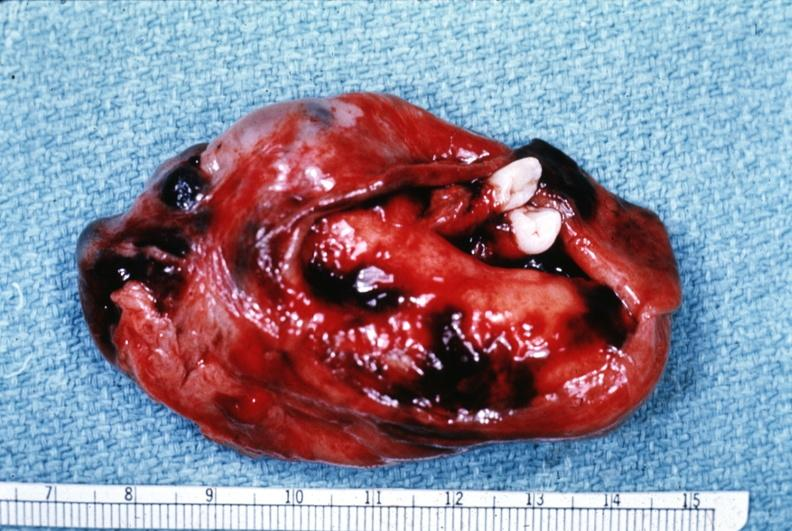what is present?
Answer the question using a single word or phrase. Ovary 